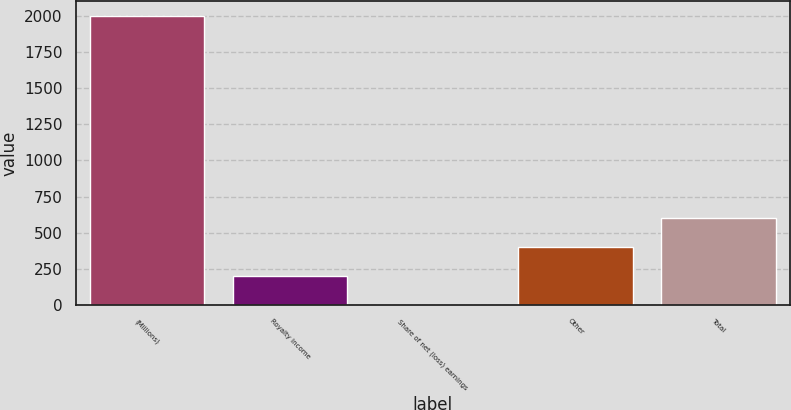<chart> <loc_0><loc_0><loc_500><loc_500><bar_chart><fcel>(Millions)<fcel>Royalty income<fcel>Share of net (loss) earnings<fcel>Other<fcel>Total<nl><fcel>2002<fcel>201.1<fcel>1<fcel>401.2<fcel>601.3<nl></chart> 